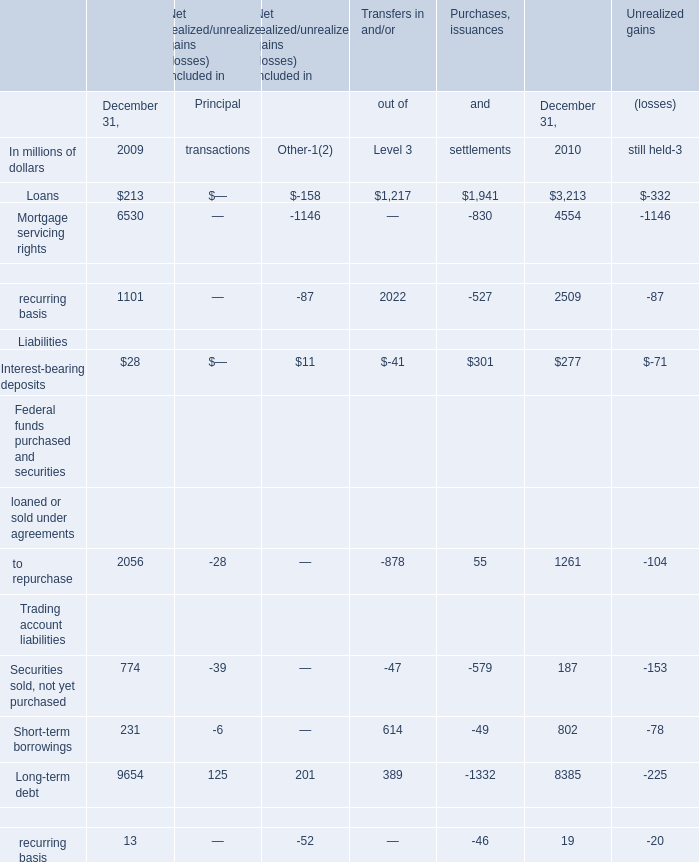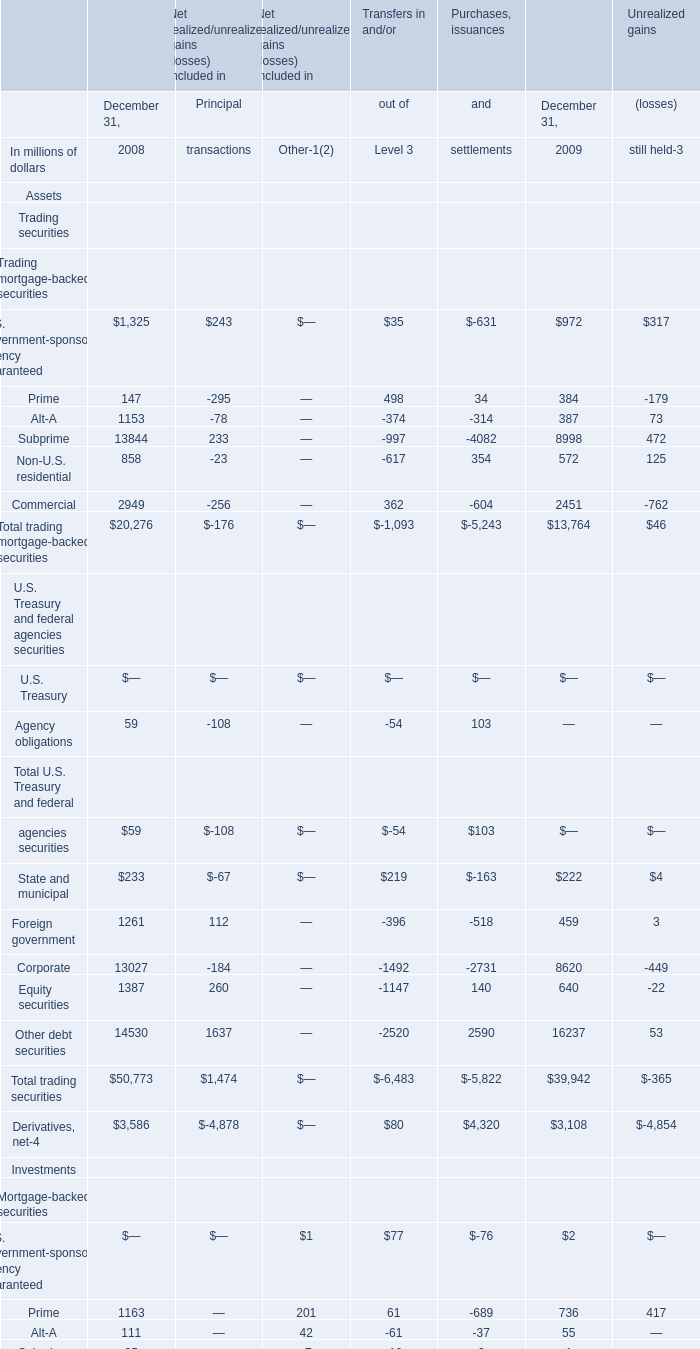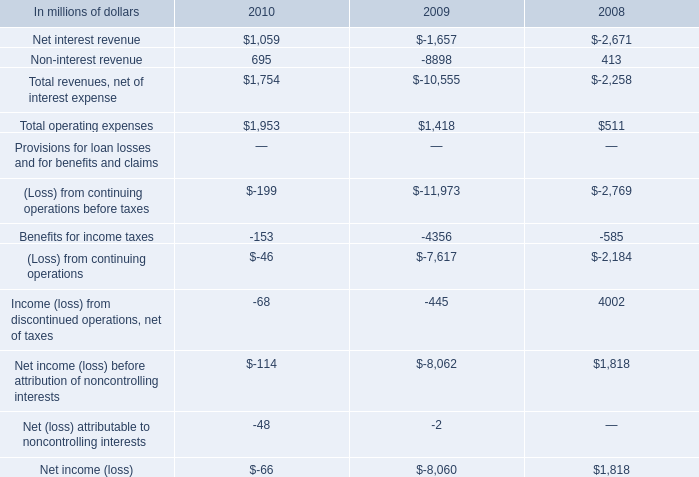What do all Liabilities sum up in 2010, excluding Interest-bearing deposits and Short-term borrowings? (in millions of dollars) 
Computations: (((1261 + 187) + 8385) + 19)
Answer: 9852.0. If Short-term borrowings develops with the same increasing rate in 2010, what will it reach in 2011? (in millions of dollars) 
Computations: (802 * (1 + ((802 - 231) / 231)))
Answer: 2784.4329. 